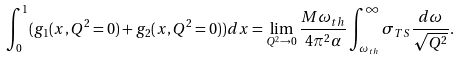Convert formula to latex. <formula><loc_0><loc_0><loc_500><loc_500>\int _ { 0 } ^ { 1 } ( g _ { 1 } ( x , Q ^ { 2 } = 0 ) + g _ { 2 } ( x , Q ^ { 2 } = 0 ) ) d x = \lim _ { Q ^ { 2 } \to 0 } \frac { M \omega _ { t h } } { 4 \pi ^ { 2 } \alpha } \int _ { \omega _ { t h } } ^ { \infty } \sigma _ { T S } \frac { d \omega } { \sqrt { Q ^ { 2 } } } .</formula> 